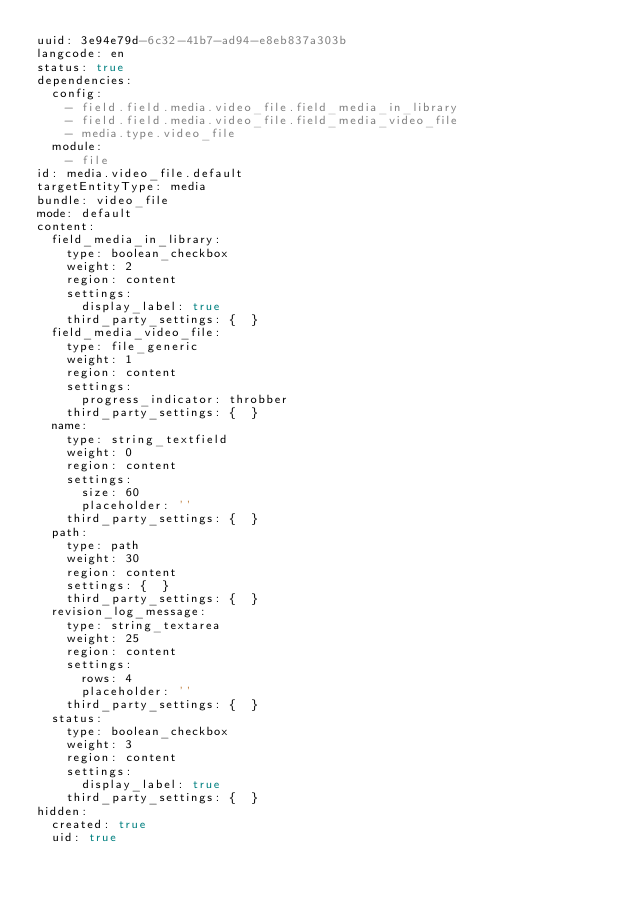Convert code to text. <code><loc_0><loc_0><loc_500><loc_500><_YAML_>uuid: 3e94e79d-6c32-41b7-ad94-e8eb837a303b
langcode: en
status: true
dependencies:
  config:
    - field.field.media.video_file.field_media_in_library
    - field.field.media.video_file.field_media_video_file
    - media.type.video_file
  module:
    - file
id: media.video_file.default
targetEntityType: media
bundle: video_file
mode: default
content:
  field_media_in_library:
    type: boolean_checkbox
    weight: 2
    region: content
    settings:
      display_label: true
    third_party_settings: {  }
  field_media_video_file:
    type: file_generic
    weight: 1
    region: content
    settings:
      progress_indicator: throbber
    third_party_settings: {  }
  name:
    type: string_textfield
    weight: 0
    region: content
    settings:
      size: 60
      placeholder: ''
    third_party_settings: {  }
  path:
    type: path
    weight: 30
    region: content
    settings: {  }
    third_party_settings: {  }
  revision_log_message:
    type: string_textarea
    weight: 25
    region: content
    settings:
      rows: 4
      placeholder: ''
    third_party_settings: {  }
  status:
    type: boolean_checkbox
    weight: 3
    region: content
    settings:
      display_label: true
    third_party_settings: {  }
hidden:
  created: true
  uid: true
</code> 